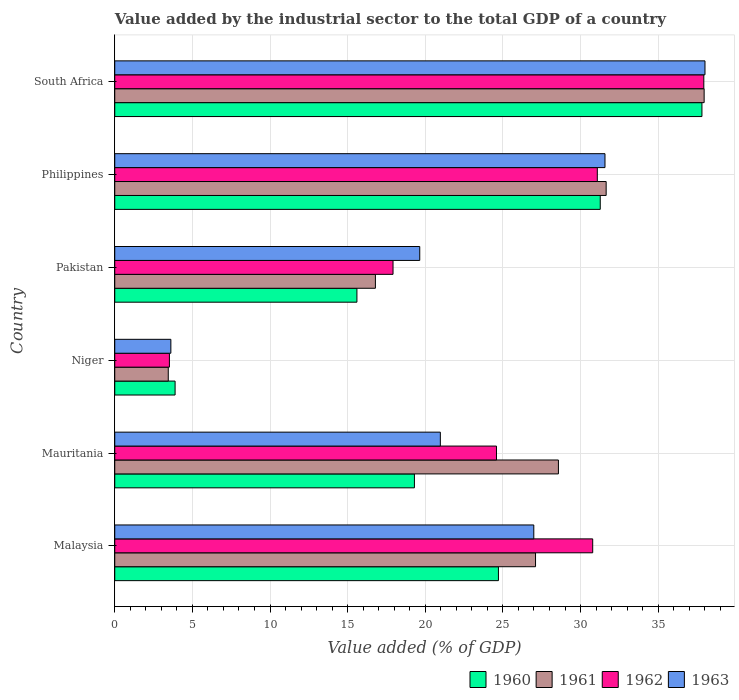How many different coloured bars are there?
Provide a short and direct response. 4. How many bars are there on the 5th tick from the top?
Your answer should be compact. 4. What is the label of the 3rd group of bars from the top?
Ensure brevity in your answer.  Pakistan. What is the value added by the industrial sector to the total GDP in 1963 in Niger?
Your answer should be compact. 3.61. Across all countries, what is the maximum value added by the industrial sector to the total GDP in 1962?
Offer a terse response. 37.94. Across all countries, what is the minimum value added by the industrial sector to the total GDP in 1963?
Keep it short and to the point. 3.61. In which country was the value added by the industrial sector to the total GDP in 1962 maximum?
Make the answer very short. South Africa. In which country was the value added by the industrial sector to the total GDP in 1960 minimum?
Your answer should be very brief. Niger. What is the total value added by the industrial sector to the total GDP in 1960 in the graph?
Make the answer very short. 132.58. What is the difference between the value added by the industrial sector to the total GDP in 1962 in Niger and that in South Africa?
Provide a succinct answer. -34.42. What is the difference between the value added by the industrial sector to the total GDP in 1963 in South Africa and the value added by the industrial sector to the total GDP in 1962 in Philippines?
Make the answer very short. 6.93. What is the average value added by the industrial sector to the total GDP in 1963 per country?
Offer a terse response. 23.47. What is the difference between the value added by the industrial sector to the total GDP in 1962 and value added by the industrial sector to the total GDP in 1963 in Philippines?
Keep it short and to the point. -0.49. What is the ratio of the value added by the industrial sector to the total GDP in 1962 in Mauritania to that in Niger?
Your response must be concise. 6.99. Is the difference between the value added by the industrial sector to the total GDP in 1962 in Malaysia and Niger greater than the difference between the value added by the industrial sector to the total GDP in 1963 in Malaysia and Niger?
Give a very brief answer. Yes. What is the difference between the highest and the second highest value added by the industrial sector to the total GDP in 1960?
Offer a terse response. 6.55. What is the difference between the highest and the lowest value added by the industrial sector to the total GDP in 1963?
Your response must be concise. 34.4. Is it the case that in every country, the sum of the value added by the industrial sector to the total GDP in 1960 and value added by the industrial sector to the total GDP in 1961 is greater than the sum of value added by the industrial sector to the total GDP in 1963 and value added by the industrial sector to the total GDP in 1962?
Keep it short and to the point. No. What does the 2nd bar from the bottom in Niger represents?
Give a very brief answer. 1961. Is it the case that in every country, the sum of the value added by the industrial sector to the total GDP in 1961 and value added by the industrial sector to the total GDP in 1962 is greater than the value added by the industrial sector to the total GDP in 1963?
Your answer should be very brief. Yes. How many countries are there in the graph?
Offer a very short reply. 6. Are the values on the major ticks of X-axis written in scientific E-notation?
Offer a terse response. No. Where does the legend appear in the graph?
Provide a short and direct response. Bottom right. How are the legend labels stacked?
Your answer should be very brief. Horizontal. What is the title of the graph?
Offer a very short reply. Value added by the industrial sector to the total GDP of a country. What is the label or title of the X-axis?
Offer a terse response. Value added (% of GDP). What is the label or title of the Y-axis?
Your answer should be very brief. Country. What is the Value added (% of GDP) in 1960 in Malaysia?
Keep it short and to the point. 24.71. What is the Value added (% of GDP) of 1961 in Malaysia?
Your answer should be very brief. 27.1. What is the Value added (% of GDP) of 1962 in Malaysia?
Ensure brevity in your answer.  30.78. What is the Value added (% of GDP) of 1963 in Malaysia?
Provide a succinct answer. 26.99. What is the Value added (% of GDP) of 1960 in Mauritania?
Offer a terse response. 19.3. What is the Value added (% of GDP) of 1961 in Mauritania?
Provide a short and direct response. 28.57. What is the Value added (% of GDP) in 1962 in Mauritania?
Your response must be concise. 24.59. What is the Value added (% of GDP) of 1963 in Mauritania?
Keep it short and to the point. 20.97. What is the Value added (% of GDP) in 1960 in Niger?
Ensure brevity in your answer.  3.89. What is the Value added (% of GDP) in 1961 in Niger?
Offer a very short reply. 3.45. What is the Value added (% of GDP) in 1962 in Niger?
Make the answer very short. 3.52. What is the Value added (% of GDP) of 1963 in Niger?
Ensure brevity in your answer.  3.61. What is the Value added (% of GDP) in 1960 in Pakistan?
Give a very brief answer. 15.6. What is the Value added (% of GDP) of 1961 in Pakistan?
Ensure brevity in your answer.  16.79. What is the Value added (% of GDP) of 1962 in Pakistan?
Offer a very short reply. 17.92. What is the Value added (% of GDP) in 1963 in Pakistan?
Your answer should be compact. 19.64. What is the Value added (% of GDP) of 1960 in Philippines?
Your answer should be very brief. 31.27. What is the Value added (% of GDP) in 1961 in Philippines?
Provide a succinct answer. 31.65. What is the Value added (% of GDP) of 1962 in Philippines?
Provide a succinct answer. 31.08. What is the Value added (% of GDP) of 1963 in Philippines?
Ensure brevity in your answer.  31.57. What is the Value added (% of GDP) of 1960 in South Africa?
Ensure brevity in your answer.  37.82. What is the Value added (% of GDP) in 1961 in South Africa?
Your response must be concise. 37.96. What is the Value added (% of GDP) in 1962 in South Africa?
Offer a very short reply. 37.94. What is the Value added (% of GDP) in 1963 in South Africa?
Make the answer very short. 38.01. Across all countries, what is the maximum Value added (% of GDP) in 1960?
Give a very brief answer. 37.82. Across all countries, what is the maximum Value added (% of GDP) of 1961?
Your response must be concise. 37.96. Across all countries, what is the maximum Value added (% of GDP) of 1962?
Ensure brevity in your answer.  37.94. Across all countries, what is the maximum Value added (% of GDP) in 1963?
Provide a succinct answer. 38.01. Across all countries, what is the minimum Value added (% of GDP) of 1960?
Your answer should be compact. 3.89. Across all countries, what is the minimum Value added (% of GDP) of 1961?
Your response must be concise. 3.45. Across all countries, what is the minimum Value added (% of GDP) of 1962?
Make the answer very short. 3.52. Across all countries, what is the minimum Value added (% of GDP) in 1963?
Your response must be concise. 3.61. What is the total Value added (% of GDP) of 1960 in the graph?
Offer a terse response. 132.58. What is the total Value added (% of GDP) in 1961 in the graph?
Provide a short and direct response. 145.51. What is the total Value added (% of GDP) of 1962 in the graph?
Keep it short and to the point. 145.83. What is the total Value added (% of GDP) of 1963 in the graph?
Provide a succinct answer. 140.8. What is the difference between the Value added (% of GDP) in 1960 in Malaysia and that in Mauritania?
Offer a terse response. 5.41. What is the difference between the Value added (% of GDP) in 1961 in Malaysia and that in Mauritania?
Your answer should be very brief. -1.47. What is the difference between the Value added (% of GDP) of 1962 in Malaysia and that in Mauritania?
Keep it short and to the point. 6.2. What is the difference between the Value added (% of GDP) in 1963 in Malaysia and that in Mauritania?
Provide a short and direct response. 6.02. What is the difference between the Value added (% of GDP) of 1960 in Malaysia and that in Niger?
Your response must be concise. 20.83. What is the difference between the Value added (% of GDP) of 1961 in Malaysia and that in Niger?
Offer a terse response. 23.65. What is the difference between the Value added (% of GDP) of 1962 in Malaysia and that in Niger?
Make the answer very short. 27.26. What is the difference between the Value added (% of GDP) in 1963 in Malaysia and that in Niger?
Keep it short and to the point. 23.38. What is the difference between the Value added (% of GDP) of 1960 in Malaysia and that in Pakistan?
Make the answer very short. 9.11. What is the difference between the Value added (% of GDP) in 1961 in Malaysia and that in Pakistan?
Provide a short and direct response. 10.31. What is the difference between the Value added (% of GDP) in 1962 in Malaysia and that in Pakistan?
Provide a succinct answer. 12.86. What is the difference between the Value added (% of GDP) in 1963 in Malaysia and that in Pakistan?
Offer a very short reply. 7.35. What is the difference between the Value added (% of GDP) in 1960 in Malaysia and that in Philippines?
Keep it short and to the point. -6.56. What is the difference between the Value added (% of GDP) of 1961 in Malaysia and that in Philippines?
Make the answer very short. -4.55. What is the difference between the Value added (% of GDP) in 1962 in Malaysia and that in Philippines?
Ensure brevity in your answer.  -0.3. What is the difference between the Value added (% of GDP) in 1963 in Malaysia and that in Philippines?
Provide a succinct answer. -4.58. What is the difference between the Value added (% of GDP) in 1960 in Malaysia and that in South Africa?
Offer a terse response. -13.11. What is the difference between the Value added (% of GDP) in 1961 in Malaysia and that in South Africa?
Your response must be concise. -10.86. What is the difference between the Value added (% of GDP) in 1962 in Malaysia and that in South Africa?
Your answer should be very brief. -7.16. What is the difference between the Value added (% of GDP) of 1963 in Malaysia and that in South Africa?
Give a very brief answer. -11.02. What is the difference between the Value added (% of GDP) in 1960 in Mauritania and that in Niger?
Give a very brief answer. 15.41. What is the difference between the Value added (% of GDP) in 1961 in Mauritania and that in Niger?
Keep it short and to the point. 25.13. What is the difference between the Value added (% of GDP) in 1962 in Mauritania and that in Niger?
Make the answer very short. 21.07. What is the difference between the Value added (% of GDP) of 1963 in Mauritania and that in Niger?
Keep it short and to the point. 17.36. What is the difference between the Value added (% of GDP) in 1960 in Mauritania and that in Pakistan?
Provide a short and direct response. 3.7. What is the difference between the Value added (% of GDP) in 1961 in Mauritania and that in Pakistan?
Keep it short and to the point. 11.79. What is the difference between the Value added (% of GDP) in 1962 in Mauritania and that in Pakistan?
Provide a succinct answer. 6.66. What is the difference between the Value added (% of GDP) of 1963 in Mauritania and that in Pakistan?
Provide a succinct answer. 1.33. What is the difference between the Value added (% of GDP) of 1960 in Mauritania and that in Philippines?
Make the answer very short. -11.97. What is the difference between the Value added (% of GDP) in 1961 in Mauritania and that in Philippines?
Your answer should be very brief. -3.07. What is the difference between the Value added (% of GDP) in 1962 in Mauritania and that in Philippines?
Offer a terse response. -6.49. What is the difference between the Value added (% of GDP) in 1963 in Mauritania and that in Philippines?
Give a very brief answer. -10.6. What is the difference between the Value added (% of GDP) in 1960 in Mauritania and that in South Africa?
Keep it short and to the point. -18.52. What is the difference between the Value added (% of GDP) of 1961 in Mauritania and that in South Africa?
Ensure brevity in your answer.  -9.38. What is the difference between the Value added (% of GDP) in 1962 in Mauritania and that in South Africa?
Your answer should be very brief. -13.35. What is the difference between the Value added (% of GDP) of 1963 in Mauritania and that in South Africa?
Your answer should be compact. -17.04. What is the difference between the Value added (% of GDP) in 1960 in Niger and that in Pakistan?
Your answer should be very brief. -11.71. What is the difference between the Value added (% of GDP) in 1961 in Niger and that in Pakistan?
Provide a short and direct response. -13.34. What is the difference between the Value added (% of GDP) in 1962 in Niger and that in Pakistan?
Your response must be concise. -14.4. What is the difference between the Value added (% of GDP) of 1963 in Niger and that in Pakistan?
Ensure brevity in your answer.  -16.03. What is the difference between the Value added (% of GDP) in 1960 in Niger and that in Philippines?
Your response must be concise. -27.38. What is the difference between the Value added (% of GDP) of 1961 in Niger and that in Philippines?
Your answer should be compact. -28.2. What is the difference between the Value added (% of GDP) of 1962 in Niger and that in Philippines?
Keep it short and to the point. -27.56. What is the difference between the Value added (% of GDP) in 1963 in Niger and that in Philippines?
Ensure brevity in your answer.  -27.96. What is the difference between the Value added (% of GDP) of 1960 in Niger and that in South Africa?
Provide a short and direct response. -33.93. What is the difference between the Value added (% of GDP) of 1961 in Niger and that in South Africa?
Offer a very short reply. -34.51. What is the difference between the Value added (% of GDP) of 1962 in Niger and that in South Africa?
Make the answer very short. -34.42. What is the difference between the Value added (% of GDP) in 1963 in Niger and that in South Africa?
Your response must be concise. -34.4. What is the difference between the Value added (% of GDP) in 1960 in Pakistan and that in Philippines?
Make the answer very short. -15.67. What is the difference between the Value added (% of GDP) of 1961 in Pakistan and that in Philippines?
Offer a very short reply. -14.86. What is the difference between the Value added (% of GDP) in 1962 in Pakistan and that in Philippines?
Provide a short and direct response. -13.16. What is the difference between the Value added (% of GDP) of 1963 in Pakistan and that in Philippines?
Provide a succinct answer. -11.93. What is the difference between the Value added (% of GDP) in 1960 in Pakistan and that in South Africa?
Your response must be concise. -22.22. What is the difference between the Value added (% of GDP) of 1961 in Pakistan and that in South Africa?
Make the answer very short. -21.17. What is the difference between the Value added (% of GDP) of 1962 in Pakistan and that in South Africa?
Your answer should be very brief. -20.02. What is the difference between the Value added (% of GDP) of 1963 in Pakistan and that in South Africa?
Make the answer very short. -18.37. What is the difference between the Value added (% of GDP) in 1960 in Philippines and that in South Africa?
Keep it short and to the point. -6.55. What is the difference between the Value added (% of GDP) of 1961 in Philippines and that in South Africa?
Your response must be concise. -6.31. What is the difference between the Value added (% of GDP) of 1962 in Philippines and that in South Africa?
Your answer should be compact. -6.86. What is the difference between the Value added (% of GDP) of 1963 in Philippines and that in South Africa?
Provide a succinct answer. -6.44. What is the difference between the Value added (% of GDP) of 1960 in Malaysia and the Value added (% of GDP) of 1961 in Mauritania?
Provide a short and direct response. -3.86. What is the difference between the Value added (% of GDP) in 1960 in Malaysia and the Value added (% of GDP) in 1962 in Mauritania?
Provide a short and direct response. 0.13. What is the difference between the Value added (% of GDP) in 1960 in Malaysia and the Value added (% of GDP) in 1963 in Mauritania?
Provide a short and direct response. 3.74. What is the difference between the Value added (% of GDP) in 1961 in Malaysia and the Value added (% of GDP) in 1962 in Mauritania?
Make the answer very short. 2.51. What is the difference between the Value added (% of GDP) of 1961 in Malaysia and the Value added (% of GDP) of 1963 in Mauritania?
Ensure brevity in your answer.  6.13. What is the difference between the Value added (% of GDP) in 1962 in Malaysia and the Value added (% of GDP) in 1963 in Mauritania?
Offer a terse response. 9.81. What is the difference between the Value added (% of GDP) in 1960 in Malaysia and the Value added (% of GDP) in 1961 in Niger?
Provide a succinct answer. 21.27. What is the difference between the Value added (% of GDP) of 1960 in Malaysia and the Value added (% of GDP) of 1962 in Niger?
Your answer should be very brief. 21.19. What is the difference between the Value added (% of GDP) in 1960 in Malaysia and the Value added (% of GDP) in 1963 in Niger?
Ensure brevity in your answer.  21.1. What is the difference between the Value added (% of GDP) in 1961 in Malaysia and the Value added (% of GDP) in 1962 in Niger?
Offer a terse response. 23.58. What is the difference between the Value added (% of GDP) in 1961 in Malaysia and the Value added (% of GDP) in 1963 in Niger?
Keep it short and to the point. 23.49. What is the difference between the Value added (% of GDP) in 1962 in Malaysia and the Value added (% of GDP) in 1963 in Niger?
Provide a short and direct response. 27.17. What is the difference between the Value added (% of GDP) in 1960 in Malaysia and the Value added (% of GDP) in 1961 in Pakistan?
Provide a short and direct response. 7.92. What is the difference between the Value added (% of GDP) of 1960 in Malaysia and the Value added (% of GDP) of 1962 in Pakistan?
Offer a very short reply. 6.79. What is the difference between the Value added (% of GDP) in 1960 in Malaysia and the Value added (% of GDP) in 1963 in Pakistan?
Ensure brevity in your answer.  5.07. What is the difference between the Value added (% of GDP) in 1961 in Malaysia and the Value added (% of GDP) in 1962 in Pakistan?
Make the answer very short. 9.18. What is the difference between the Value added (% of GDP) of 1961 in Malaysia and the Value added (% of GDP) of 1963 in Pakistan?
Offer a terse response. 7.46. What is the difference between the Value added (% of GDP) of 1962 in Malaysia and the Value added (% of GDP) of 1963 in Pakistan?
Keep it short and to the point. 11.14. What is the difference between the Value added (% of GDP) of 1960 in Malaysia and the Value added (% of GDP) of 1961 in Philippines?
Make the answer very short. -6.94. What is the difference between the Value added (% of GDP) of 1960 in Malaysia and the Value added (% of GDP) of 1962 in Philippines?
Offer a very short reply. -6.37. What is the difference between the Value added (% of GDP) of 1960 in Malaysia and the Value added (% of GDP) of 1963 in Philippines?
Your answer should be very brief. -6.86. What is the difference between the Value added (% of GDP) of 1961 in Malaysia and the Value added (% of GDP) of 1962 in Philippines?
Offer a very short reply. -3.98. What is the difference between the Value added (% of GDP) in 1961 in Malaysia and the Value added (% of GDP) in 1963 in Philippines?
Ensure brevity in your answer.  -4.47. What is the difference between the Value added (% of GDP) of 1962 in Malaysia and the Value added (% of GDP) of 1963 in Philippines?
Your response must be concise. -0.79. What is the difference between the Value added (% of GDP) of 1960 in Malaysia and the Value added (% of GDP) of 1961 in South Africa?
Offer a terse response. -13.25. What is the difference between the Value added (% of GDP) in 1960 in Malaysia and the Value added (% of GDP) in 1962 in South Africa?
Your answer should be very brief. -13.23. What is the difference between the Value added (% of GDP) in 1960 in Malaysia and the Value added (% of GDP) in 1963 in South Africa?
Your answer should be very brief. -13.3. What is the difference between the Value added (% of GDP) in 1961 in Malaysia and the Value added (% of GDP) in 1962 in South Africa?
Your answer should be compact. -10.84. What is the difference between the Value added (% of GDP) in 1961 in Malaysia and the Value added (% of GDP) in 1963 in South Africa?
Make the answer very short. -10.91. What is the difference between the Value added (% of GDP) in 1962 in Malaysia and the Value added (% of GDP) in 1963 in South Africa?
Offer a very short reply. -7.23. What is the difference between the Value added (% of GDP) in 1960 in Mauritania and the Value added (% of GDP) in 1961 in Niger?
Your answer should be very brief. 15.85. What is the difference between the Value added (% of GDP) in 1960 in Mauritania and the Value added (% of GDP) in 1962 in Niger?
Offer a terse response. 15.78. What is the difference between the Value added (% of GDP) of 1960 in Mauritania and the Value added (% of GDP) of 1963 in Niger?
Your response must be concise. 15.69. What is the difference between the Value added (% of GDP) in 1961 in Mauritania and the Value added (% of GDP) in 1962 in Niger?
Offer a terse response. 25.05. What is the difference between the Value added (% of GDP) in 1961 in Mauritania and the Value added (% of GDP) in 1963 in Niger?
Provide a succinct answer. 24.96. What is the difference between the Value added (% of GDP) of 1962 in Mauritania and the Value added (% of GDP) of 1963 in Niger?
Give a very brief answer. 20.97. What is the difference between the Value added (% of GDP) in 1960 in Mauritania and the Value added (% of GDP) in 1961 in Pakistan?
Provide a succinct answer. 2.51. What is the difference between the Value added (% of GDP) of 1960 in Mauritania and the Value added (% of GDP) of 1962 in Pakistan?
Provide a succinct answer. 1.38. What is the difference between the Value added (% of GDP) of 1960 in Mauritania and the Value added (% of GDP) of 1963 in Pakistan?
Provide a succinct answer. -0.34. What is the difference between the Value added (% of GDP) of 1961 in Mauritania and the Value added (% of GDP) of 1962 in Pakistan?
Provide a succinct answer. 10.65. What is the difference between the Value added (% of GDP) of 1961 in Mauritania and the Value added (% of GDP) of 1963 in Pakistan?
Ensure brevity in your answer.  8.93. What is the difference between the Value added (% of GDP) of 1962 in Mauritania and the Value added (% of GDP) of 1963 in Pakistan?
Your answer should be very brief. 4.94. What is the difference between the Value added (% of GDP) of 1960 in Mauritania and the Value added (% of GDP) of 1961 in Philippines?
Provide a short and direct response. -12.35. What is the difference between the Value added (% of GDP) of 1960 in Mauritania and the Value added (% of GDP) of 1962 in Philippines?
Your answer should be compact. -11.78. What is the difference between the Value added (% of GDP) in 1960 in Mauritania and the Value added (% of GDP) in 1963 in Philippines?
Make the answer very short. -12.27. What is the difference between the Value added (% of GDP) in 1961 in Mauritania and the Value added (% of GDP) in 1962 in Philippines?
Offer a very short reply. -2.51. What is the difference between the Value added (% of GDP) in 1961 in Mauritania and the Value added (% of GDP) in 1963 in Philippines?
Offer a very short reply. -3. What is the difference between the Value added (% of GDP) in 1962 in Mauritania and the Value added (% of GDP) in 1963 in Philippines?
Provide a short and direct response. -6.99. What is the difference between the Value added (% of GDP) in 1960 in Mauritania and the Value added (% of GDP) in 1961 in South Africa?
Provide a succinct answer. -18.66. What is the difference between the Value added (% of GDP) in 1960 in Mauritania and the Value added (% of GDP) in 1962 in South Africa?
Provide a succinct answer. -18.64. What is the difference between the Value added (% of GDP) of 1960 in Mauritania and the Value added (% of GDP) of 1963 in South Africa?
Make the answer very short. -18.71. What is the difference between the Value added (% of GDP) of 1961 in Mauritania and the Value added (% of GDP) of 1962 in South Africa?
Provide a short and direct response. -9.36. What is the difference between the Value added (% of GDP) in 1961 in Mauritania and the Value added (% of GDP) in 1963 in South Africa?
Ensure brevity in your answer.  -9.44. What is the difference between the Value added (% of GDP) in 1962 in Mauritania and the Value added (% of GDP) in 1963 in South Africa?
Make the answer very short. -13.43. What is the difference between the Value added (% of GDP) of 1960 in Niger and the Value added (% of GDP) of 1961 in Pakistan?
Give a very brief answer. -12.9. What is the difference between the Value added (% of GDP) in 1960 in Niger and the Value added (% of GDP) in 1962 in Pakistan?
Provide a short and direct response. -14.04. What is the difference between the Value added (% of GDP) in 1960 in Niger and the Value added (% of GDP) in 1963 in Pakistan?
Give a very brief answer. -15.76. What is the difference between the Value added (% of GDP) of 1961 in Niger and the Value added (% of GDP) of 1962 in Pakistan?
Keep it short and to the point. -14.48. What is the difference between the Value added (% of GDP) in 1961 in Niger and the Value added (% of GDP) in 1963 in Pakistan?
Your response must be concise. -16.2. What is the difference between the Value added (% of GDP) in 1962 in Niger and the Value added (% of GDP) in 1963 in Pakistan?
Ensure brevity in your answer.  -16.12. What is the difference between the Value added (% of GDP) in 1960 in Niger and the Value added (% of GDP) in 1961 in Philippines?
Keep it short and to the point. -27.76. What is the difference between the Value added (% of GDP) of 1960 in Niger and the Value added (% of GDP) of 1962 in Philippines?
Your answer should be compact. -27.19. What is the difference between the Value added (% of GDP) of 1960 in Niger and the Value added (% of GDP) of 1963 in Philippines?
Give a very brief answer. -27.69. What is the difference between the Value added (% of GDP) in 1961 in Niger and the Value added (% of GDP) in 1962 in Philippines?
Your answer should be very brief. -27.63. What is the difference between the Value added (% of GDP) of 1961 in Niger and the Value added (% of GDP) of 1963 in Philippines?
Ensure brevity in your answer.  -28.13. What is the difference between the Value added (% of GDP) of 1962 in Niger and the Value added (% of GDP) of 1963 in Philippines?
Offer a terse response. -28.05. What is the difference between the Value added (% of GDP) in 1960 in Niger and the Value added (% of GDP) in 1961 in South Africa?
Offer a very short reply. -34.07. What is the difference between the Value added (% of GDP) of 1960 in Niger and the Value added (% of GDP) of 1962 in South Africa?
Provide a succinct answer. -34.05. What is the difference between the Value added (% of GDP) of 1960 in Niger and the Value added (% of GDP) of 1963 in South Africa?
Your answer should be very brief. -34.13. What is the difference between the Value added (% of GDP) of 1961 in Niger and the Value added (% of GDP) of 1962 in South Africa?
Offer a terse response. -34.49. What is the difference between the Value added (% of GDP) of 1961 in Niger and the Value added (% of GDP) of 1963 in South Africa?
Make the answer very short. -34.57. What is the difference between the Value added (% of GDP) in 1962 in Niger and the Value added (% of GDP) in 1963 in South Africa?
Offer a terse response. -34.49. What is the difference between the Value added (% of GDP) in 1960 in Pakistan and the Value added (% of GDP) in 1961 in Philippines?
Give a very brief answer. -16.05. What is the difference between the Value added (% of GDP) in 1960 in Pakistan and the Value added (% of GDP) in 1962 in Philippines?
Offer a very short reply. -15.48. What is the difference between the Value added (% of GDP) of 1960 in Pakistan and the Value added (% of GDP) of 1963 in Philippines?
Your answer should be very brief. -15.98. What is the difference between the Value added (% of GDP) in 1961 in Pakistan and the Value added (% of GDP) in 1962 in Philippines?
Offer a very short reply. -14.29. What is the difference between the Value added (% of GDP) in 1961 in Pakistan and the Value added (% of GDP) in 1963 in Philippines?
Give a very brief answer. -14.79. What is the difference between the Value added (% of GDP) of 1962 in Pakistan and the Value added (% of GDP) of 1963 in Philippines?
Provide a succinct answer. -13.65. What is the difference between the Value added (% of GDP) in 1960 in Pakistan and the Value added (% of GDP) in 1961 in South Africa?
Offer a very short reply. -22.36. What is the difference between the Value added (% of GDP) in 1960 in Pakistan and the Value added (% of GDP) in 1962 in South Africa?
Make the answer very short. -22.34. What is the difference between the Value added (% of GDP) in 1960 in Pakistan and the Value added (% of GDP) in 1963 in South Africa?
Ensure brevity in your answer.  -22.42. What is the difference between the Value added (% of GDP) in 1961 in Pakistan and the Value added (% of GDP) in 1962 in South Africa?
Provide a succinct answer. -21.15. What is the difference between the Value added (% of GDP) in 1961 in Pakistan and the Value added (% of GDP) in 1963 in South Africa?
Keep it short and to the point. -21.23. What is the difference between the Value added (% of GDP) in 1962 in Pakistan and the Value added (% of GDP) in 1963 in South Africa?
Give a very brief answer. -20.09. What is the difference between the Value added (% of GDP) of 1960 in Philippines and the Value added (% of GDP) of 1961 in South Africa?
Your answer should be compact. -6.69. What is the difference between the Value added (% of GDP) in 1960 in Philippines and the Value added (% of GDP) in 1962 in South Africa?
Your answer should be compact. -6.67. What is the difference between the Value added (% of GDP) of 1960 in Philippines and the Value added (% of GDP) of 1963 in South Africa?
Your response must be concise. -6.75. What is the difference between the Value added (% of GDP) in 1961 in Philippines and the Value added (% of GDP) in 1962 in South Africa?
Your answer should be compact. -6.29. What is the difference between the Value added (% of GDP) in 1961 in Philippines and the Value added (% of GDP) in 1963 in South Africa?
Your answer should be compact. -6.37. What is the difference between the Value added (% of GDP) in 1962 in Philippines and the Value added (% of GDP) in 1963 in South Africa?
Ensure brevity in your answer.  -6.93. What is the average Value added (% of GDP) in 1960 per country?
Your answer should be very brief. 22.1. What is the average Value added (% of GDP) of 1961 per country?
Give a very brief answer. 24.25. What is the average Value added (% of GDP) in 1962 per country?
Give a very brief answer. 24.3. What is the average Value added (% of GDP) in 1963 per country?
Provide a succinct answer. 23.47. What is the difference between the Value added (% of GDP) in 1960 and Value added (% of GDP) in 1961 in Malaysia?
Give a very brief answer. -2.39. What is the difference between the Value added (% of GDP) in 1960 and Value added (% of GDP) in 1962 in Malaysia?
Offer a terse response. -6.07. What is the difference between the Value added (% of GDP) in 1960 and Value added (% of GDP) in 1963 in Malaysia?
Make the answer very short. -2.28. What is the difference between the Value added (% of GDP) of 1961 and Value added (% of GDP) of 1962 in Malaysia?
Make the answer very short. -3.68. What is the difference between the Value added (% of GDP) in 1961 and Value added (% of GDP) in 1963 in Malaysia?
Provide a succinct answer. 0.11. What is the difference between the Value added (% of GDP) in 1962 and Value added (% of GDP) in 1963 in Malaysia?
Your answer should be compact. 3.79. What is the difference between the Value added (% of GDP) in 1960 and Value added (% of GDP) in 1961 in Mauritania?
Your answer should be compact. -9.27. What is the difference between the Value added (% of GDP) in 1960 and Value added (% of GDP) in 1962 in Mauritania?
Your response must be concise. -5.29. What is the difference between the Value added (% of GDP) in 1960 and Value added (% of GDP) in 1963 in Mauritania?
Keep it short and to the point. -1.67. What is the difference between the Value added (% of GDP) in 1961 and Value added (% of GDP) in 1962 in Mauritania?
Keep it short and to the point. 3.99. What is the difference between the Value added (% of GDP) of 1961 and Value added (% of GDP) of 1963 in Mauritania?
Give a very brief answer. 7.6. What is the difference between the Value added (% of GDP) of 1962 and Value added (% of GDP) of 1963 in Mauritania?
Give a very brief answer. 3.62. What is the difference between the Value added (% of GDP) of 1960 and Value added (% of GDP) of 1961 in Niger?
Provide a short and direct response. 0.44. What is the difference between the Value added (% of GDP) of 1960 and Value added (% of GDP) of 1962 in Niger?
Provide a succinct answer. 0.37. What is the difference between the Value added (% of GDP) in 1960 and Value added (% of GDP) in 1963 in Niger?
Your response must be concise. 0.27. What is the difference between the Value added (% of GDP) of 1961 and Value added (% of GDP) of 1962 in Niger?
Provide a short and direct response. -0.07. What is the difference between the Value added (% of GDP) of 1961 and Value added (% of GDP) of 1963 in Niger?
Offer a very short reply. -0.17. What is the difference between the Value added (% of GDP) of 1962 and Value added (% of GDP) of 1963 in Niger?
Your response must be concise. -0.09. What is the difference between the Value added (% of GDP) of 1960 and Value added (% of GDP) of 1961 in Pakistan?
Your response must be concise. -1.19. What is the difference between the Value added (% of GDP) in 1960 and Value added (% of GDP) in 1962 in Pakistan?
Your response must be concise. -2.33. What is the difference between the Value added (% of GDP) in 1960 and Value added (% of GDP) in 1963 in Pakistan?
Give a very brief answer. -4.05. What is the difference between the Value added (% of GDP) in 1961 and Value added (% of GDP) in 1962 in Pakistan?
Your answer should be very brief. -1.14. What is the difference between the Value added (% of GDP) in 1961 and Value added (% of GDP) in 1963 in Pakistan?
Your answer should be very brief. -2.86. What is the difference between the Value added (% of GDP) in 1962 and Value added (% of GDP) in 1963 in Pakistan?
Give a very brief answer. -1.72. What is the difference between the Value added (% of GDP) of 1960 and Value added (% of GDP) of 1961 in Philippines?
Provide a short and direct response. -0.38. What is the difference between the Value added (% of GDP) of 1960 and Value added (% of GDP) of 1962 in Philippines?
Keep it short and to the point. 0.19. What is the difference between the Value added (% of GDP) in 1960 and Value added (% of GDP) in 1963 in Philippines?
Your answer should be compact. -0.3. What is the difference between the Value added (% of GDP) in 1961 and Value added (% of GDP) in 1962 in Philippines?
Ensure brevity in your answer.  0.57. What is the difference between the Value added (% of GDP) of 1961 and Value added (% of GDP) of 1963 in Philippines?
Provide a short and direct response. 0.08. What is the difference between the Value added (% of GDP) of 1962 and Value added (% of GDP) of 1963 in Philippines?
Ensure brevity in your answer.  -0.49. What is the difference between the Value added (% of GDP) in 1960 and Value added (% of GDP) in 1961 in South Africa?
Offer a terse response. -0.14. What is the difference between the Value added (% of GDP) of 1960 and Value added (% of GDP) of 1962 in South Africa?
Your answer should be very brief. -0.12. What is the difference between the Value added (% of GDP) in 1960 and Value added (% of GDP) in 1963 in South Africa?
Your response must be concise. -0.2. What is the difference between the Value added (% of GDP) of 1961 and Value added (% of GDP) of 1962 in South Africa?
Offer a terse response. 0.02. What is the difference between the Value added (% of GDP) of 1961 and Value added (% of GDP) of 1963 in South Africa?
Make the answer very short. -0.05. What is the difference between the Value added (% of GDP) of 1962 and Value added (% of GDP) of 1963 in South Africa?
Your answer should be very brief. -0.08. What is the ratio of the Value added (% of GDP) of 1960 in Malaysia to that in Mauritania?
Offer a terse response. 1.28. What is the ratio of the Value added (% of GDP) of 1961 in Malaysia to that in Mauritania?
Ensure brevity in your answer.  0.95. What is the ratio of the Value added (% of GDP) in 1962 in Malaysia to that in Mauritania?
Give a very brief answer. 1.25. What is the ratio of the Value added (% of GDP) in 1963 in Malaysia to that in Mauritania?
Your response must be concise. 1.29. What is the ratio of the Value added (% of GDP) of 1960 in Malaysia to that in Niger?
Your answer should be compact. 6.36. What is the ratio of the Value added (% of GDP) in 1961 in Malaysia to that in Niger?
Your answer should be very brief. 7.86. What is the ratio of the Value added (% of GDP) of 1962 in Malaysia to that in Niger?
Ensure brevity in your answer.  8.75. What is the ratio of the Value added (% of GDP) of 1963 in Malaysia to that in Niger?
Provide a succinct answer. 7.47. What is the ratio of the Value added (% of GDP) of 1960 in Malaysia to that in Pakistan?
Give a very brief answer. 1.58. What is the ratio of the Value added (% of GDP) of 1961 in Malaysia to that in Pakistan?
Offer a terse response. 1.61. What is the ratio of the Value added (% of GDP) in 1962 in Malaysia to that in Pakistan?
Provide a short and direct response. 1.72. What is the ratio of the Value added (% of GDP) of 1963 in Malaysia to that in Pakistan?
Offer a terse response. 1.37. What is the ratio of the Value added (% of GDP) of 1960 in Malaysia to that in Philippines?
Keep it short and to the point. 0.79. What is the ratio of the Value added (% of GDP) in 1961 in Malaysia to that in Philippines?
Your response must be concise. 0.86. What is the ratio of the Value added (% of GDP) in 1963 in Malaysia to that in Philippines?
Your answer should be very brief. 0.85. What is the ratio of the Value added (% of GDP) of 1960 in Malaysia to that in South Africa?
Give a very brief answer. 0.65. What is the ratio of the Value added (% of GDP) in 1961 in Malaysia to that in South Africa?
Make the answer very short. 0.71. What is the ratio of the Value added (% of GDP) in 1962 in Malaysia to that in South Africa?
Your answer should be compact. 0.81. What is the ratio of the Value added (% of GDP) of 1963 in Malaysia to that in South Africa?
Your response must be concise. 0.71. What is the ratio of the Value added (% of GDP) in 1960 in Mauritania to that in Niger?
Keep it short and to the point. 4.97. What is the ratio of the Value added (% of GDP) of 1961 in Mauritania to that in Niger?
Ensure brevity in your answer.  8.29. What is the ratio of the Value added (% of GDP) in 1962 in Mauritania to that in Niger?
Your answer should be very brief. 6.99. What is the ratio of the Value added (% of GDP) of 1963 in Mauritania to that in Niger?
Give a very brief answer. 5.8. What is the ratio of the Value added (% of GDP) in 1960 in Mauritania to that in Pakistan?
Offer a terse response. 1.24. What is the ratio of the Value added (% of GDP) in 1961 in Mauritania to that in Pakistan?
Give a very brief answer. 1.7. What is the ratio of the Value added (% of GDP) in 1962 in Mauritania to that in Pakistan?
Offer a very short reply. 1.37. What is the ratio of the Value added (% of GDP) of 1963 in Mauritania to that in Pakistan?
Your answer should be very brief. 1.07. What is the ratio of the Value added (% of GDP) in 1960 in Mauritania to that in Philippines?
Provide a succinct answer. 0.62. What is the ratio of the Value added (% of GDP) of 1961 in Mauritania to that in Philippines?
Offer a very short reply. 0.9. What is the ratio of the Value added (% of GDP) in 1962 in Mauritania to that in Philippines?
Ensure brevity in your answer.  0.79. What is the ratio of the Value added (% of GDP) in 1963 in Mauritania to that in Philippines?
Provide a short and direct response. 0.66. What is the ratio of the Value added (% of GDP) of 1960 in Mauritania to that in South Africa?
Keep it short and to the point. 0.51. What is the ratio of the Value added (% of GDP) of 1961 in Mauritania to that in South Africa?
Ensure brevity in your answer.  0.75. What is the ratio of the Value added (% of GDP) of 1962 in Mauritania to that in South Africa?
Your response must be concise. 0.65. What is the ratio of the Value added (% of GDP) in 1963 in Mauritania to that in South Africa?
Your answer should be compact. 0.55. What is the ratio of the Value added (% of GDP) in 1960 in Niger to that in Pakistan?
Make the answer very short. 0.25. What is the ratio of the Value added (% of GDP) in 1961 in Niger to that in Pakistan?
Keep it short and to the point. 0.21. What is the ratio of the Value added (% of GDP) of 1962 in Niger to that in Pakistan?
Your response must be concise. 0.2. What is the ratio of the Value added (% of GDP) of 1963 in Niger to that in Pakistan?
Keep it short and to the point. 0.18. What is the ratio of the Value added (% of GDP) of 1960 in Niger to that in Philippines?
Provide a succinct answer. 0.12. What is the ratio of the Value added (% of GDP) of 1961 in Niger to that in Philippines?
Provide a short and direct response. 0.11. What is the ratio of the Value added (% of GDP) of 1962 in Niger to that in Philippines?
Provide a short and direct response. 0.11. What is the ratio of the Value added (% of GDP) in 1963 in Niger to that in Philippines?
Offer a very short reply. 0.11. What is the ratio of the Value added (% of GDP) of 1960 in Niger to that in South Africa?
Offer a very short reply. 0.1. What is the ratio of the Value added (% of GDP) in 1961 in Niger to that in South Africa?
Your response must be concise. 0.09. What is the ratio of the Value added (% of GDP) in 1962 in Niger to that in South Africa?
Your answer should be very brief. 0.09. What is the ratio of the Value added (% of GDP) in 1963 in Niger to that in South Africa?
Ensure brevity in your answer.  0.1. What is the ratio of the Value added (% of GDP) in 1960 in Pakistan to that in Philippines?
Make the answer very short. 0.5. What is the ratio of the Value added (% of GDP) in 1961 in Pakistan to that in Philippines?
Offer a terse response. 0.53. What is the ratio of the Value added (% of GDP) in 1962 in Pakistan to that in Philippines?
Your response must be concise. 0.58. What is the ratio of the Value added (% of GDP) of 1963 in Pakistan to that in Philippines?
Provide a succinct answer. 0.62. What is the ratio of the Value added (% of GDP) of 1960 in Pakistan to that in South Africa?
Your answer should be very brief. 0.41. What is the ratio of the Value added (% of GDP) in 1961 in Pakistan to that in South Africa?
Provide a succinct answer. 0.44. What is the ratio of the Value added (% of GDP) of 1962 in Pakistan to that in South Africa?
Offer a terse response. 0.47. What is the ratio of the Value added (% of GDP) in 1963 in Pakistan to that in South Africa?
Your answer should be compact. 0.52. What is the ratio of the Value added (% of GDP) of 1960 in Philippines to that in South Africa?
Keep it short and to the point. 0.83. What is the ratio of the Value added (% of GDP) of 1961 in Philippines to that in South Africa?
Ensure brevity in your answer.  0.83. What is the ratio of the Value added (% of GDP) in 1962 in Philippines to that in South Africa?
Your answer should be very brief. 0.82. What is the ratio of the Value added (% of GDP) in 1963 in Philippines to that in South Africa?
Your answer should be very brief. 0.83. What is the difference between the highest and the second highest Value added (% of GDP) in 1960?
Provide a short and direct response. 6.55. What is the difference between the highest and the second highest Value added (% of GDP) of 1961?
Offer a very short reply. 6.31. What is the difference between the highest and the second highest Value added (% of GDP) in 1962?
Your response must be concise. 6.86. What is the difference between the highest and the second highest Value added (% of GDP) in 1963?
Provide a succinct answer. 6.44. What is the difference between the highest and the lowest Value added (% of GDP) in 1960?
Provide a short and direct response. 33.93. What is the difference between the highest and the lowest Value added (% of GDP) of 1961?
Keep it short and to the point. 34.51. What is the difference between the highest and the lowest Value added (% of GDP) of 1962?
Your answer should be very brief. 34.42. What is the difference between the highest and the lowest Value added (% of GDP) of 1963?
Provide a short and direct response. 34.4. 